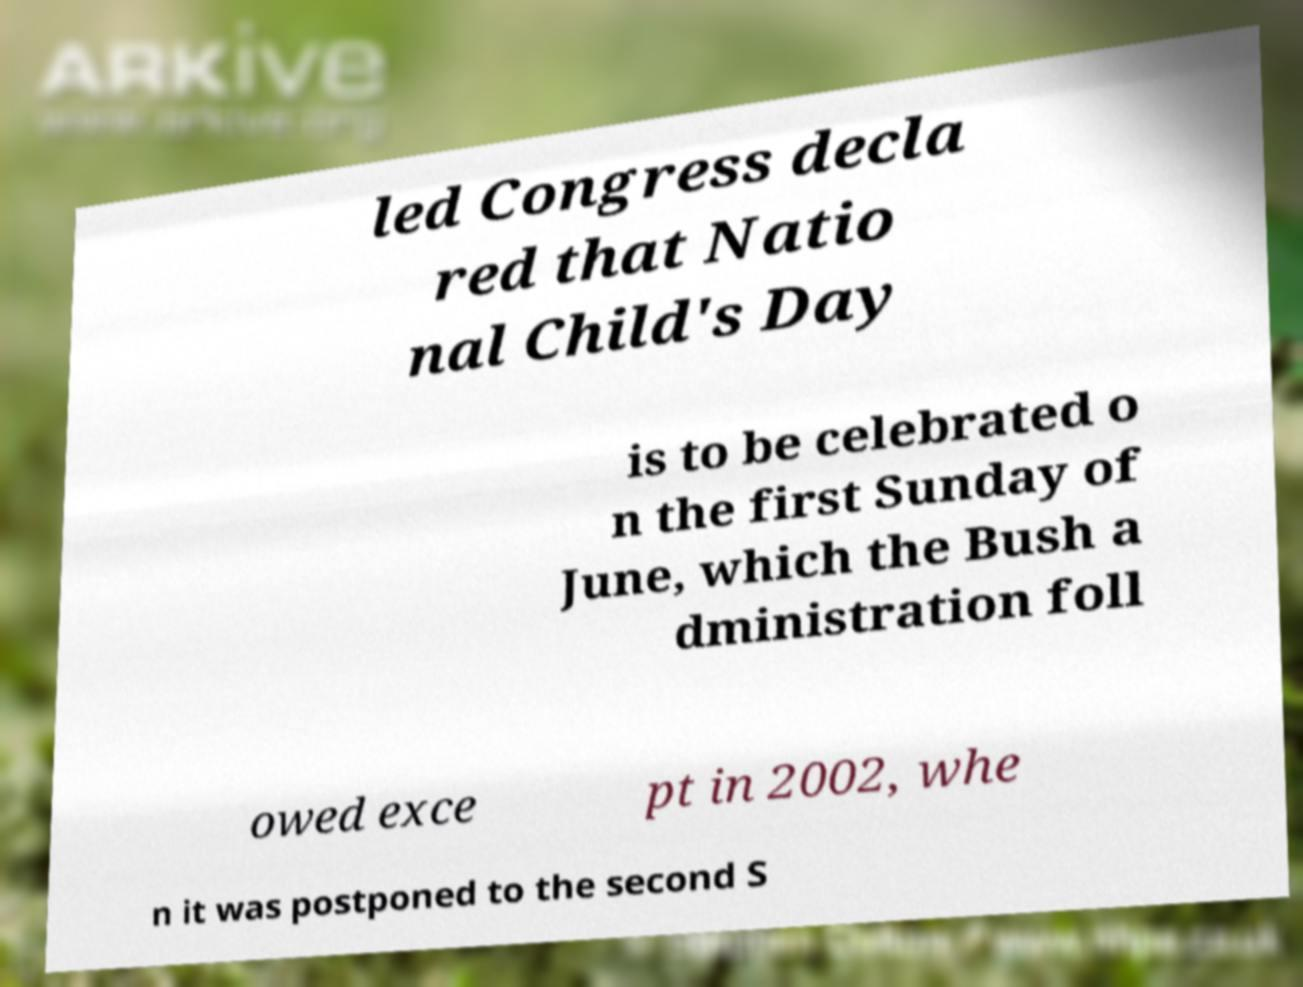Could you assist in decoding the text presented in this image and type it out clearly? led Congress decla red that Natio nal Child's Day is to be celebrated o n the first Sunday of June, which the Bush a dministration foll owed exce pt in 2002, whe n it was postponed to the second S 